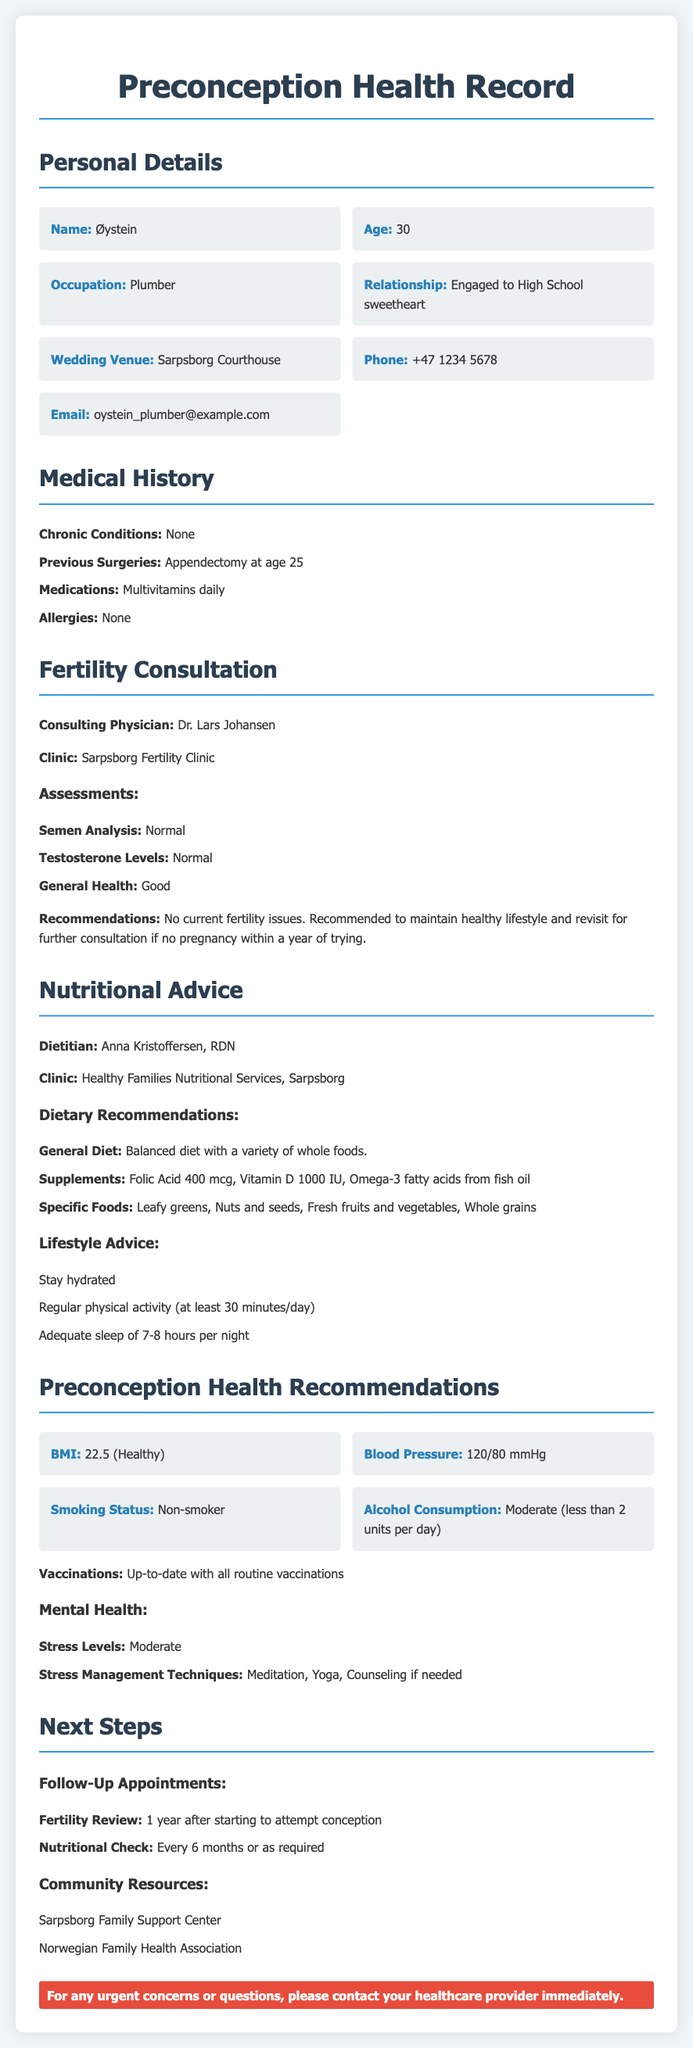what is Øystein's age? Øystein's age is specified in the personal details section of the document.
Answer: 30 who is Øystein engaged to? The document states Øystein is engaged to his high school sweetheart in the personal details section.
Answer: High School sweetheart what is the name of the consulting physician for fertility? The name of the consulting physician is mentioned under the fertility consultation section.
Answer: Dr. Lars Johansen what were the testosterone levels reported? Testosterone levels are mentioned in the fertility consultation assessments along with other health indicators.
Answer: Normal what dietary supplement is Øystein advised to take? The nutritional advice section lists supplements recommended for Øystein's diet.
Answer: Folic Acid 400 mcg what is Øystein's BMI? The document includes this information in the preconception health recommendations section under vital signs.
Answer: 22.5 how often should Øystein have a nutritional check? This information is provided in the next steps section focused on follow-up appointments.
Answer: Every 6 months what lifestyle advice is given for physical activity? The lifestyle advice section states a specific recommendation regarding physical activity frequency.
Answer: at least 30 minutes/day what is the alcohol consumption level categorized as? The document mentions Øystein's alcohol consumption in the preconception health recommendations.
Answer: Moderate (less than 2 units per day) 